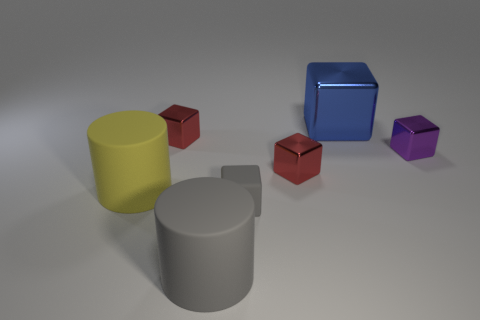How many big yellow things are behind the small shiny cube that is to the right of the big blue block?
Ensure brevity in your answer.  0. Is there a tiny yellow cylinder?
Provide a short and direct response. No. How many other objects are there of the same color as the big shiny cube?
Provide a short and direct response. 0. Is the number of large gray cylinders less than the number of red shiny cubes?
Offer a terse response. Yes. There is a red shiny object that is left of the gray rubber object that is in front of the gray block; what shape is it?
Your answer should be compact. Cube. Are there any metal blocks behind the purple object?
Offer a terse response. Yes. There is another rubber thing that is the same size as the purple object; what is its color?
Provide a succinct answer. Gray. How many large blue blocks have the same material as the purple object?
Ensure brevity in your answer.  1. What number of other things are the same size as the gray rubber cylinder?
Offer a terse response. 2. Are there any yellow metallic things that have the same size as the gray cylinder?
Make the answer very short. No. 